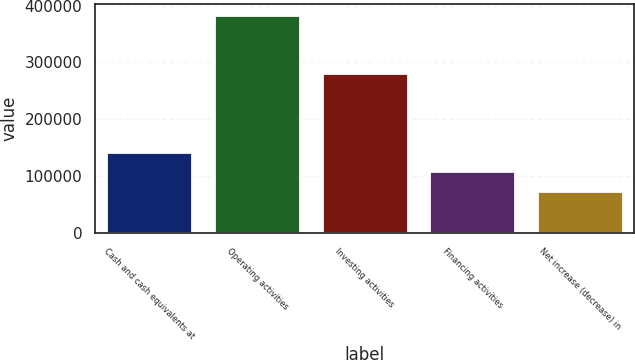Convert chart to OTSL. <chart><loc_0><loc_0><loc_500><loc_500><bar_chart><fcel>Cash and cash equivalents at<fcel>Operating activities<fcel>Investing activities<fcel>Financing activities<fcel>Net increase (decrease) in<nl><fcel>142955<fcel>384192<fcel>281512<fcel>108493<fcel>74030.4<nl></chart> 